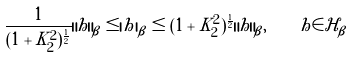Convert formula to latex. <formula><loc_0><loc_0><loc_500><loc_500>\frac { 1 } { ( 1 + K _ { 2 } ^ { 2 } ) ^ { \frac { 1 } { 2 } } } \| h \| _ { \beta } \leq | h | _ { \beta } \leq ( 1 + K _ { 2 } ^ { 2 } ) ^ { \frac { 1 } { 2 } } \| h \| _ { \beta } , \quad h \in \mathcal { H } _ { \beta }</formula> 